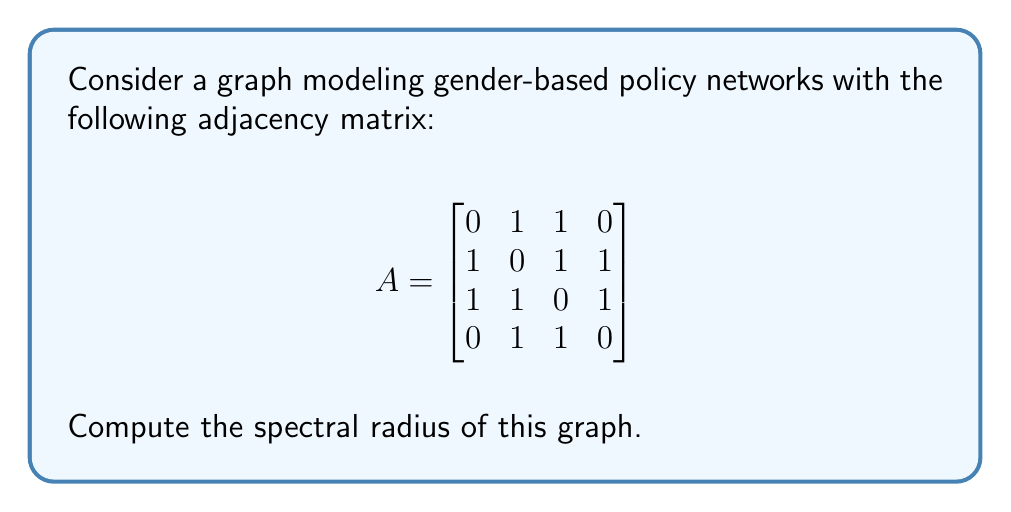Could you help me with this problem? To compute the spectral radius of the graph, we need to follow these steps:

1) The spectral radius is the largest absolute eigenvalue of the adjacency matrix.

2) To find the eigenvalues, we need to solve the characteristic equation:
   $$det(A - \lambda I) = 0$$

3) Expanding the determinant:
   $$\begin{vmatrix}
   -\lambda & 1 & 1 & 0 \\
   1 & -\lambda & 1 & 1 \\
   1 & 1 & -\lambda & 1 \\
   0 & 1 & 1 & -\lambda
   \end{vmatrix} = 0$$

4) Calculating the determinant:
   $$\lambda^4 - 3\lambda^2 - 4\lambda + 1 = 0$$

5) This is a fourth-degree polynomial equation. While it can be solved analytically, it's complex. Using numerical methods, we find the roots are approximately:
   $$\lambda_1 \approx 2.4812, \lambda_2 \approx -1.7016, \lambda_3 \approx 0.6651, \lambda_4 \approx -0.4447$$

6) The spectral radius is the largest absolute value among these eigenvalues, which is $|\lambda_1| \approx 2.4812$.
Answer: $2.4812$ (rounded to 4 decimal places) 